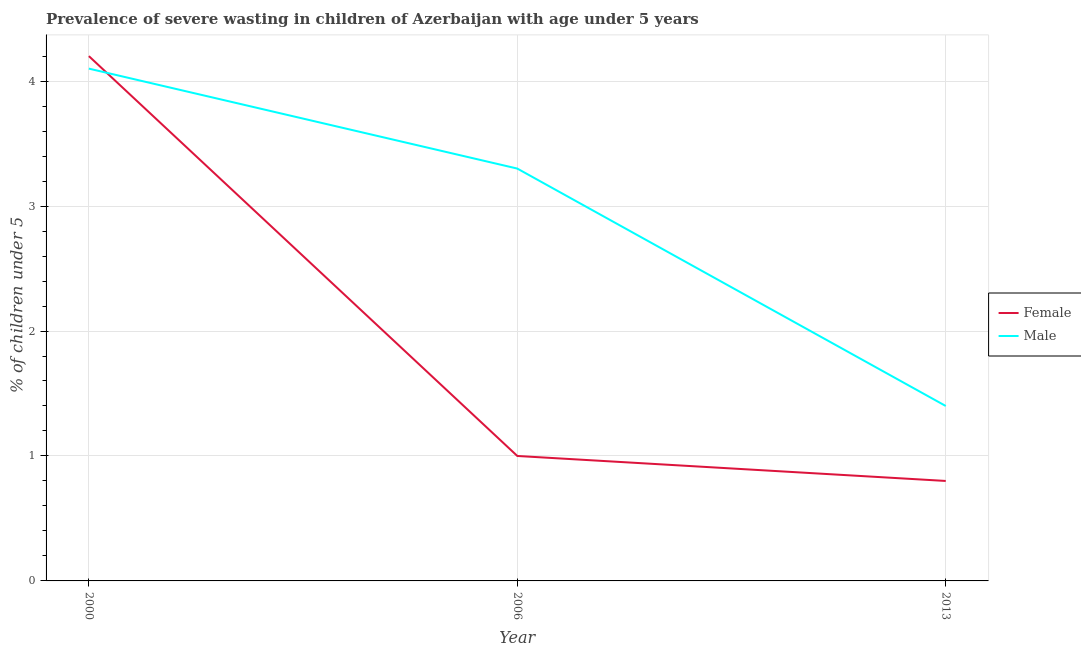How many different coloured lines are there?
Offer a very short reply. 2. Is the number of lines equal to the number of legend labels?
Offer a very short reply. Yes. What is the percentage of undernourished male children in 2006?
Keep it short and to the point. 3.3. Across all years, what is the maximum percentage of undernourished male children?
Your answer should be very brief. 4.1. Across all years, what is the minimum percentage of undernourished female children?
Offer a terse response. 0.8. What is the total percentage of undernourished female children in the graph?
Your response must be concise. 6. What is the difference between the percentage of undernourished male children in 2000 and that in 2013?
Make the answer very short. 2.7. What is the difference between the percentage of undernourished male children in 2006 and the percentage of undernourished female children in 2000?
Ensure brevity in your answer.  -0.9. What is the average percentage of undernourished male children per year?
Make the answer very short. 2.93. In the year 2006, what is the difference between the percentage of undernourished male children and percentage of undernourished female children?
Keep it short and to the point. 2.3. In how many years, is the percentage of undernourished female children greater than 2.4 %?
Your answer should be very brief. 1. What is the ratio of the percentage of undernourished male children in 2000 to that in 2006?
Offer a terse response. 1.24. Is the percentage of undernourished male children in 2000 less than that in 2013?
Keep it short and to the point. No. Is the difference between the percentage of undernourished male children in 2000 and 2013 greater than the difference between the percentage of undernourished female children in 2000 and 2013?
Your response must be concise. No. What is the difference between the highest and the second highest percentage of undernourished female children?
Your answer should be very brief. 3.2. What is the difference between the highest and the lowest percentage of undernourished female children?
Keep it short and to the point. 3.4. Does the percentage of undernourished male children monotonically increase over the years?
Give a very brief answer. No. Is the percentage of undernourished male children strictly greater than the percentage of undernourished female children over the years?
Your answer should be very brief. No. What is the difference between two consecutive major ticks on the Y-axis?
Provide a short and direct response. 1. Are the values on the major ticks of Y-axis written in scientific E-notation?
Your answer should be very brief. No. Does the graph contain any zero values?
Give a very brief answer. No. How many legend labels are there?
Give a very brief answer. 2. What is the title of the graph?
Your response must be concise. Prevalence of severe wasting in children of Azerbaijan with age under 5 years. Does "Merchandise imports" appear as one of the legend labels in the graph?
Your answer should be very brief. No. What is the label or title of the X-axis?
Provide a short and direct response. Year. What is the label or title of the Y-axis?
Make the answer very short.  % of children under 5. What is the  % of children under 5 of Female in 2000?
Make the answer very short. 4.2. What is the  % of children under 5 in Male in 2000?
Offer a very short reply. 4.1. What is the  % of children under 5 of Female in 2006?
Provide a succinct answer. 1. What is the  % of children under 5 in Male in 2006?
Offer a terse response. 3.3. What is the  % of children under 5 in Female in 2013?
Your answer should be compact. 0.8. What is the  % of children under 5 of Male in 2013?
Ensure brevity in your answer.  1.4. Across all years, what is the maximum  % of children under 5 in Female?
Make the answer very short. 4.2. Across all years, what is the maximum  % of children under 5 in Male?
Provide a succinct answer. 4.1. Across all years, what is the minimum  % of children under 5 of Female?
Offer a very short reply. 0.8. Across all years, what is the minimum  % of children under 5 of Male?
Make the answer very short. 1.4. What is the total  % of children under 5 in Female in the graph?
Your answer should be compact. 6. What is the total  % of children under 5 of Male in the graph?
Give a very brief answer. 8.8. What is the difference between the  % of children under 5 in Female in 2000 and that in 2006?
Ensure brevity in your answer.  3.2. What is the difference between the  % of children under 5 in Male in 2000 and that in 2006?
Give a very brief answer. 0.8. What is the difference between the  % of children under 5 of Female in 2006 and that in 2013?
Your response must be concise. 0.2. What is the difference between the  % of children under 5 of Female in 2000 and the  % of children under 5 of Male in 2013?
Provide a succinct answer. 2.8. What is the difference between the  % of children under 5 in Female in 2006 and the  % of children under 5 in Male in 2013?
Your answer should be very brief. -0.4. What is the average  % of children under 5 of Female per year?
Make the answer very short. 2. What is the average  % of children under 5 of Male per year?
Make the answer very short. 2.93. In the year 2000, what is the difference between the  % of children under 5 in Female and  % of children under 5 in Male?
Provide a succinct answer. 0.1. In the year 2013, what is the difference between the  % of children under 5 of Female and  % of children under 5 of Male?
Give a very brief answer. -0.6. What is the ratio of the  % of children under 5 in Female in 2000 to that in 2006?
Your answer should be very brief. 4.2. What is the ratio of the  % of children under 5 of Male in 2000 to that in 2006?
Keep it short and to the point. 1.24. What is the ratio of the  % of children under 5 of Female in 2000 to that in 2013?
Your response must be concise. 5.25. What is the ratio of the  % of children under 5 of Male in 2000 to that in 2013?
Your answer should be compact. 2.93. What is the ratio of the  % of children under 5 of Male in 2006 to that in 2013?
Offer a terse response. 2.36. What is the difference between the highest and the second highest  % of children under 5 in Female?
Make the answer very short. 3.2. What is the difference between the highest and the lowest  % of children under 5 in Male?
Your answer should be compact. 2.7. 